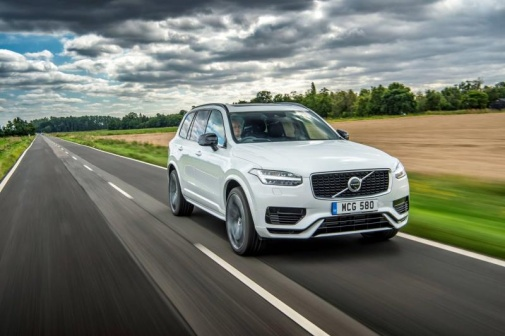What do you see happening in this image? The image shows a white Volvo XC90 SUV driving along a newly paved two-lane highway. The vehicle is in the right lane, heading towards the horizon, with its license plate 'MC6 580' clearly visible. The surrounding scenery is picturesque, featuring lush green fields and dense trees on both sides of the highway. The sky is cloudy, suggesting the possibility of rain. The wet road surface indicates that it likely rained recently, creating a serene and refreshing atmosphere for a countryside drive. 